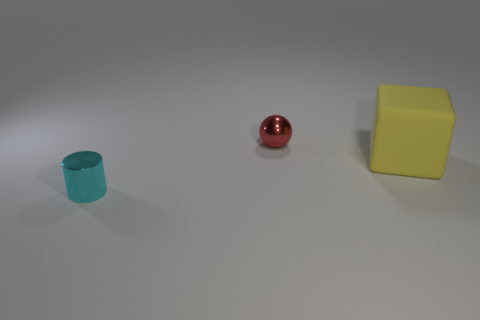What objects can be identified in this scene based on their shape? In the scene, there is a cyan cylinder, a red sphere, and a yellow cube. Are these objects arranged in any particular pattern? The objects are placed with even spacing on a flat surface, without any discernible pattern beyond their linear arrangement. 